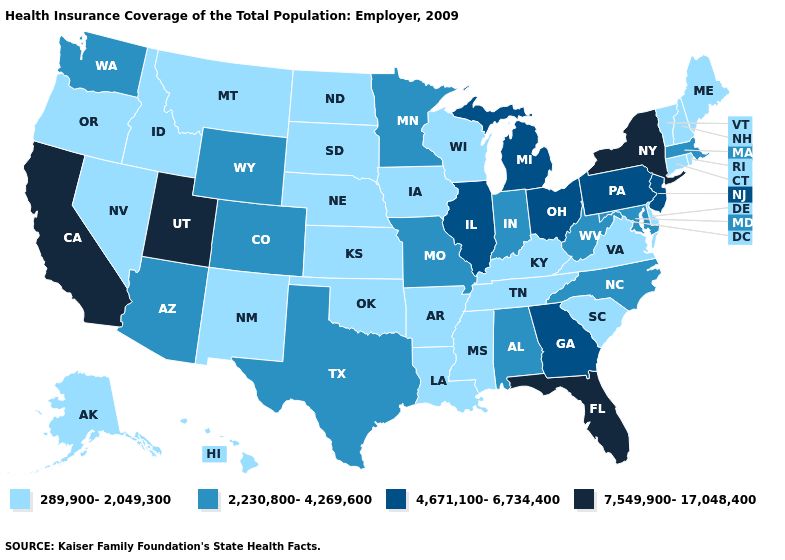What is the value of Nebraska?
Short answer required. 289,900-2,049,300. Does Wyoming have a lower value than Pennsylvania?
Short answer required. Yes. Name the states that have a value in the range 4,671,100-6,734,400?
Short answer required. Georgia, Illinois, Michigan, New Jersey, Ohio, Pennsylvania. Does California have the highest value in the USA?
Give a very brief answer. Yes. What is the value of Oregon?
Concise answer only. 289,900-2,049,300. What is the highest value in the MidWest ?
Short answer required. 4,671,100-6,734,400. What is the value of New Hampshire?
Be succinct. 289,900-2,049,300. Which states have the lowest value in the MidWest?
Quick response, please. Iowa, Kansas, Nebraska, North Dakota, South Dakota, Wisconsin. Does Minnesota have the highest value in the USA?
Be succinct. No. Which states have the lowest value in the Northeast?
Answer briefly. Connecticut, Maine, New Hampshire, Rhode Island, Vermont. What is the value of Nevada?
Write a very short answer. 289,900-2,049,300. Name the states that have a value in the range 7,549,900-17,048,400?
Keep it brief. California, Florida, New York, Utah. What is the value of Indiana?
Short answer required. 2,230,800-4,269,600. Does New Jersey have the same value as Vermont?
Concise answer only. No. Name the states that have a value in the range 2,230,800-4,269,600?
Write a very short answer. Alabama, Arizona, Colorado, Indiana, Maryland, Massachusetts, Minnesota, Missouri, North Carolina, Texas, Washington, West Virginia, Wyoming. 